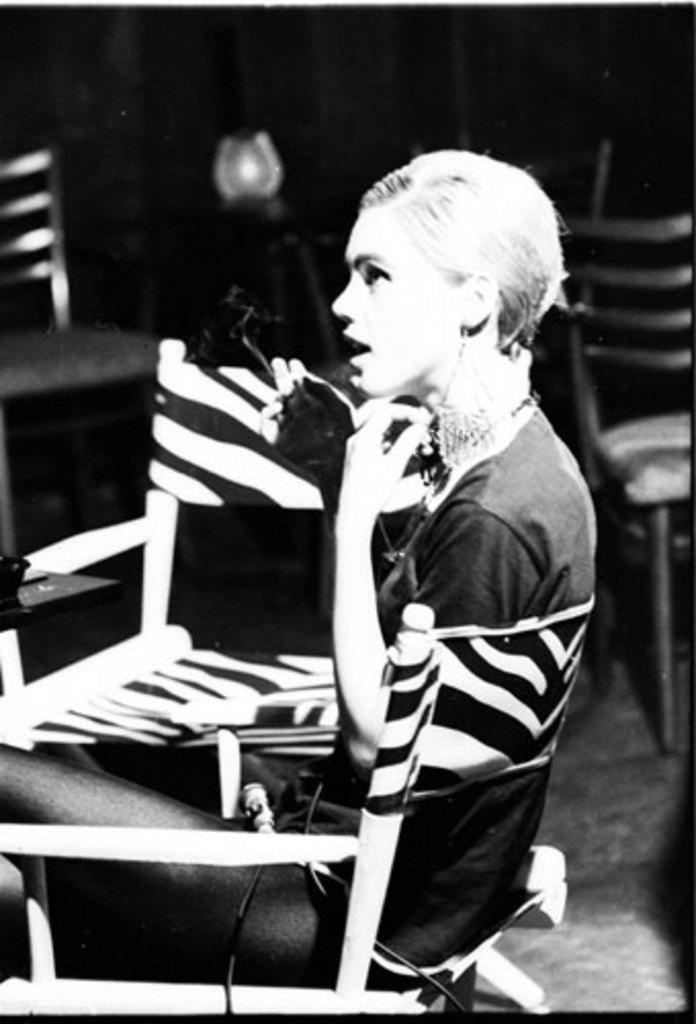What is the color scheme of the picture? The picture is black and white. Who is in the picture? There is a woman in the picture. What is the woman doing in the picture? The woman is sitting on a chair. What type of celery is the woman holding in the picture? There is no celery present in the picture; it is a black and white image of a woman sitting on a chair. 